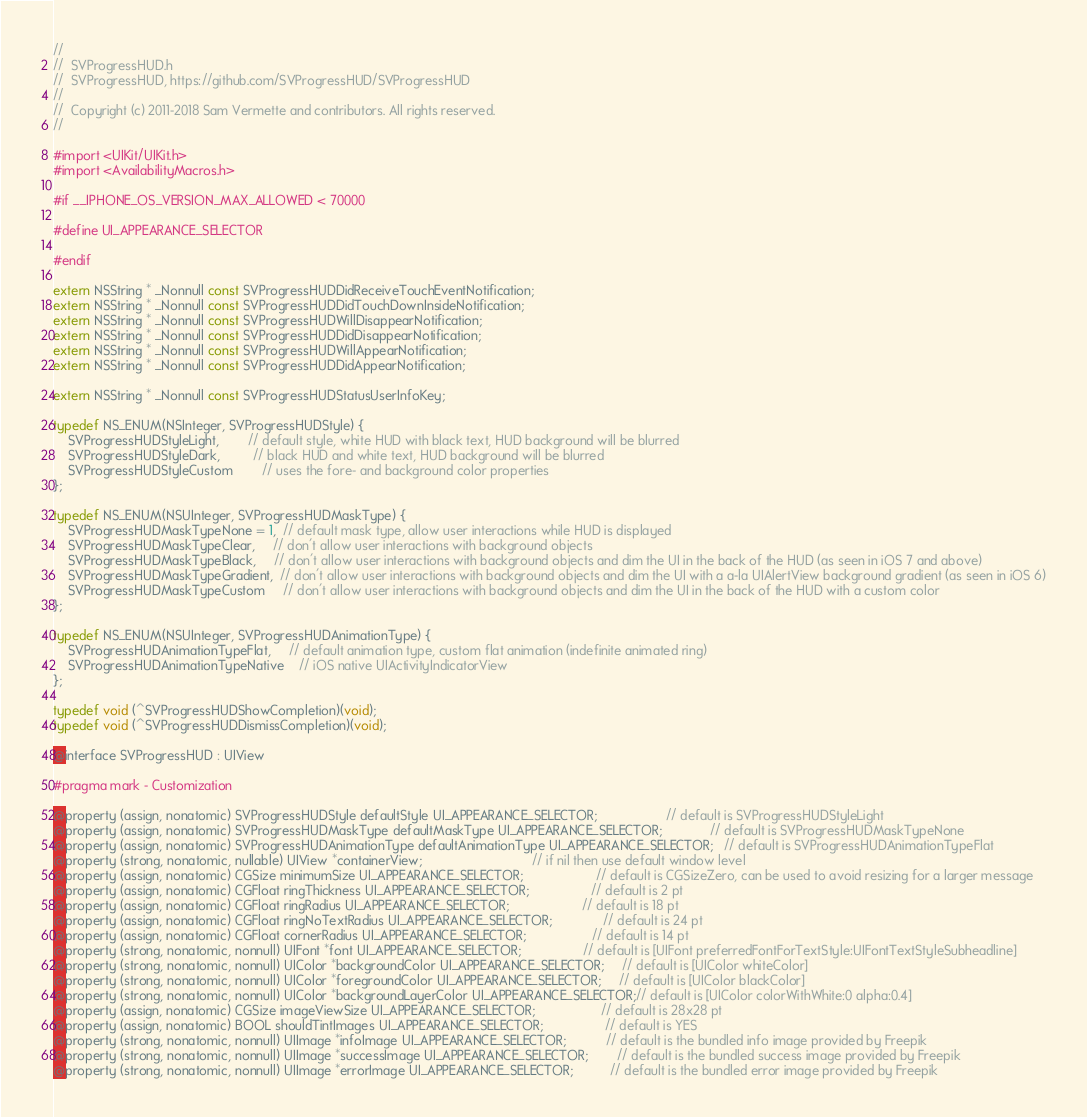<code> <loc_0><loc_0><loc_500><loc_500><_C_>//
//  SVProgressHUD.h
//  SVProgressHUD, https://github.com/SVProgressHUD/SVProgressHUD
//
//  Copyright (c) 2011-2018 Sam Vermette and contributors. All rights reserved.
//

#import <UIKit/UIKit.h>
#import <AvailabilityMacros.h>

#if __IPHONE_OS_VERSION_MAX_ALLOWED < 70000

#define UI_APPEARANCE_SELECTOR

#endif

extern NSString * _Nonnull const SVProgressHUDDidReceiveTouchEventNotification;
extern NSString * _Nonnull const SVProgressHUDDidTouchDownInsideNotification;
extern NSString * _Nonnull const SVProgressHUDWillDisappearNotification;
extern NSString * _Nonnull const SVProgressHUDDidDisappearNotification;
extern NSString * _Nonnull const SVProgressHUDWillAppearNotification;
extern NSString * _Nonnull const SVProgressHUDDidAppearNotification;

extern NSString * _Nonnull const SVProgressHUDStatusUserInfoKey;

typedef NS_ENUM(NSInteger, SVProgressHUDStyle) {
    SVProgressHUDStyleLight,        // default style, white HUD with black text, HUD background will be blurred
    SVProgressHUDStyleDark,         // black HUD and white text, HUD background will be blurred
    SVProgressHUDStyleCustom        // uses the fore- and background color properties
};

typedef NS_ENUM(NSUInteger, SVProgressHUDMaskType) {
    SVProgressHUDMaskTypeNone = 1,  // default mask type, allow user interactions while HUD is displayed
    SVProgressHUDMaskTypeClear,     // don't allow user interactions with background objects
    SVProgressHUDMaskTypeBlack,     // don't allow user interactions with background objects and dim the UI in the back of the HUD (as seen in iOS 7 and above)
    SVProgressHUDMaskTypeGradient,  // don't allow user interactions with background objects and dim the UI with a a-la UIAlertView background gradient (as seen in iOS 6)
    SVProgressHUDMaskTypeCustom     // don't allow user interactions with background objects and dim the UI in the back of the HUD with a custom color
};

typedef NS_ENUM(NSUInteger, SVProgressHUDAnimationType) {
    SVProgressHUDAnimationTypeFlat,     // default animation type, custom flat animation (indefinite animated ring)
    SVProgressHUDAnimationTypeNative    // iOS native UIActivityIndicatorView
};

typedef void (^SVProgressHUDShowCompletion)(void);
typedef void (^SVProgressHUDDismissCompletion)(void);

@interface SVProgressHUD : UIView

#pragma mark - Customization

@property (assign, nonatomic) SVProgressHUDStyle defaultStyle UI_APPEARANCE_SELECTOR;                   // default is SVProgressHUDStyleLight
@property (assign, nonatomic) SVProgressHUDMaskType defaultMaskType UI_APPEARANCE_SELECTOR;             // default is SVProgressHUDMaskTypeNone
@property (assign, nonatomic) SVProgressHUDAnimationType defaultAnimationType UI_APPEARANCE_SELECTOR;   // default is SVProgressHUDAnimationTypeFlat
@property (strong, nonatomic, nullable) UIView *containerView;                              // if nil then use default window level
@property (assign, nonatomic) CGSize minimumSize UI_APPEARANCE_SELECTOR;                    // default is CGSizeZero, can be used to avoid resizing for a larger message
@property (assign, nonatomic) CGFloat ringThickness UI_APPEARANCE_SELECTOR;                 // default is 2 pt
@property (assign, nonatomic) CGFloat ringRadius UI_APPEARANCE_SELECTOR;                    // default is 18 pt
@property (assign, nonatomic) CGFloat ringNoTextRadius UI_APPEARANCE_SELECTOR;              // default is 24 pt
@property (assign, nonatomic) CGFloat cornerRadius UI_APPEARANCE_SELECTOR;                  // default is 14 pt
@property (strong, nonatomic, nonnull) UIFont *font UI_APPEARANCE_SELECTOR;                 // default is [UIFont preferredFontForTextStyle:UIFontTextStyleSubheadline]
@property (strong, nonatomic, nonnull) UIColor *backgroundColor UI_APPEARANCE_SELECTOR;     // default is [UIColor whiteColor]
@property (strong, nonatomic, nonnull) UIColor *foregroundColor UI_APPEARANCE_SELECTOR;     // default is [UIColor blackColor]
@property (strong, nonatomic, nonnull) UIColor *backgroundLayerColor UI_APPEARANCE_SELECTOR;// default is [UIColor colorWithWhite:0 alpha:0.4]
@property (assign, nonatomic) CGSize imageViewSize UI_APPEARANCE_SELECTOR;                  // default is 28x28 pt
@property (assign, nonatomic) BOOL shouldTintImages UI_APPEARANCE_SELECTOR;                 // default is YES
@property (strong, nonatomic, nonnull) UIImage *infoImage UI_APPEARANCE_SELECTOR;           // default is the bundled info image provided by Freepik
@property (strong, nonatomic, nonnull) UIImage *successImage UI_APPEARANCE_SELECTOR;        // default is the bundled success image provided by Freepik
@property (strong, nonatomic, nonnull) UIImage *errorImage UI_APPEARANCE_SELECTOR;          // default is the bundled error image provided by Freepik</code> 